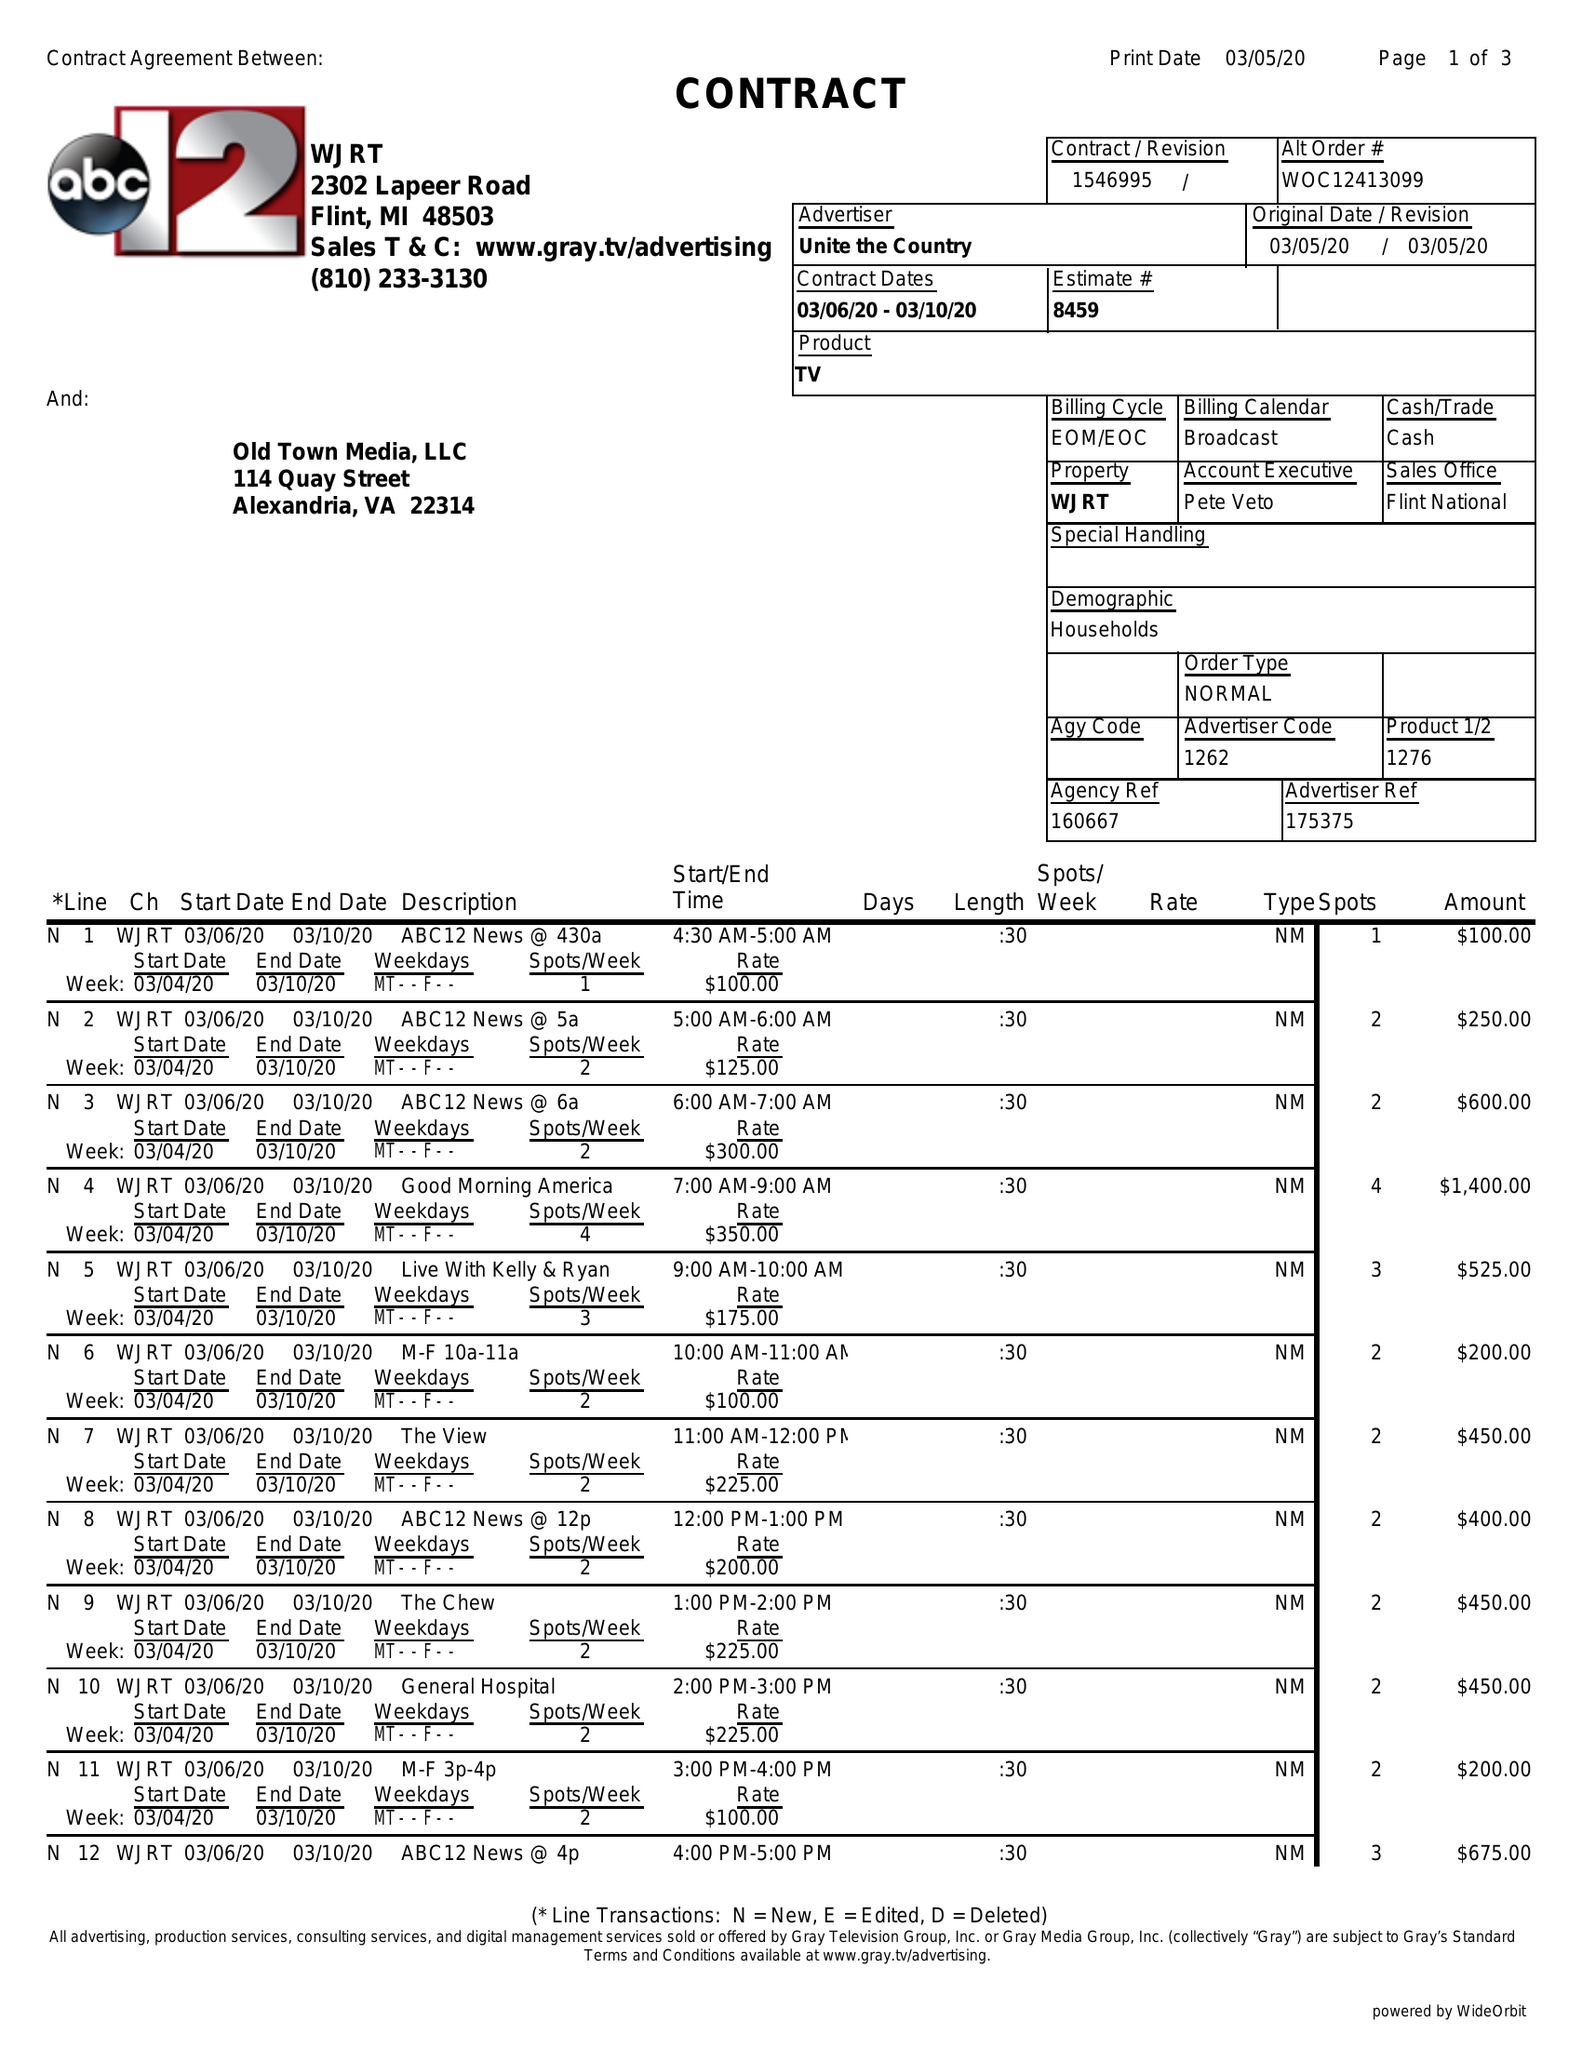What is the value for the advertiser?
Answer the question using a single word or phrase. UNITE THE COUNTRY 